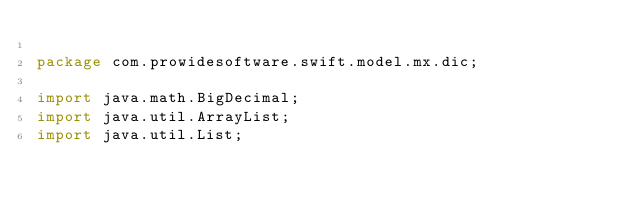Convert code to text. <code><loc_0><loc_0><loc_500><loc_500><_Java_>
package com.prowidesoftware.swift.model.mx.dic;

import java.math.BigDecimal;
import java.util.ArrayList;
import java.util.List;</code> 